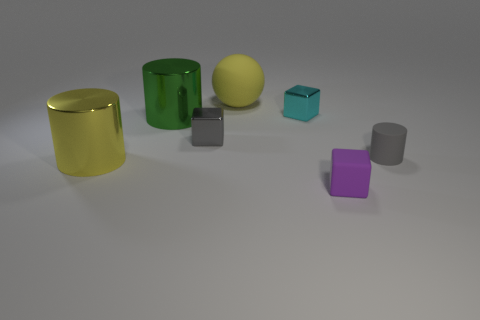Do the yellow thing in front of the yellow sphere and the matte thing behind the gray rubber object have the same shape?
Make the answer very short. No. What number of small gray objects are on the right side of the tiny gray thing that is right of the yellow thing that is to the right of the yellow cylinder?
Your answer should be very brief. 0. There is a large green cylinder that is on the left side of the small gray matte cylinder behind the small block that is on the right side of the small cyan block; what is its material?
Provide a short and direct response. Metal. Are the cylinder that is right of the yellow rubber thing and the ball made of the same material?
Give a very brief answer. Yes. What number of green cylinders are the same size as the purple rubber block?
Your answer should be very brief. 0. Is the number of balls that are in front of the cyan metallic cube greater than the number of yellow rubber things that are in front of the gray cube?
Your answer should be very brief. No. Are there any yellow matte things that have the same shape as the green object?
Your response must be concise. No. There is a yellow thing that is behind the tiny object behind the green object; what size is it?
Keep it short and to the point. Large. There is a large yellow object that is in front of the matte thing to the right of the small rubber thing in front of the yellow metallic cylinder; what is its shape?
Provide a short and direct response. Cylinder. There is a gray object that is the same material as the green cylinder; what size is it?
Ensure brevity in your answer.  Small. 